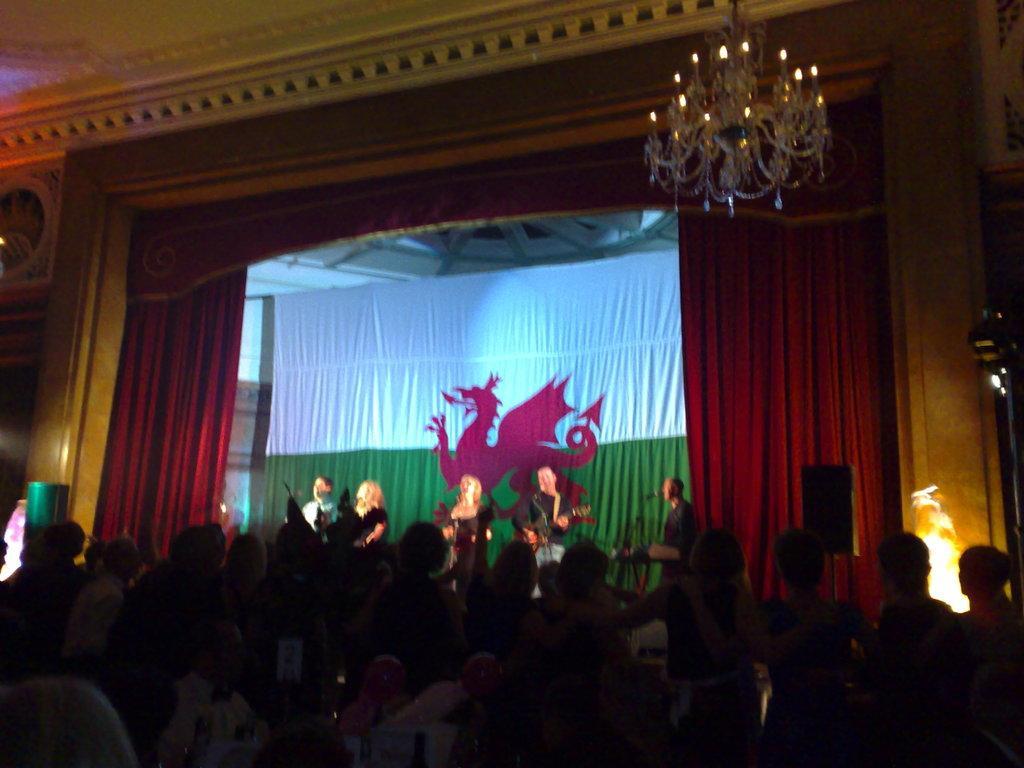Describe this image in one or two sentences. In the foreground of this image, there are persons standing and few are sitting on the chairs. In the background, on the stage, there are few persons performing in front of mics, a flag, curtain, chandelier to the ceiling, wall and few lights. 